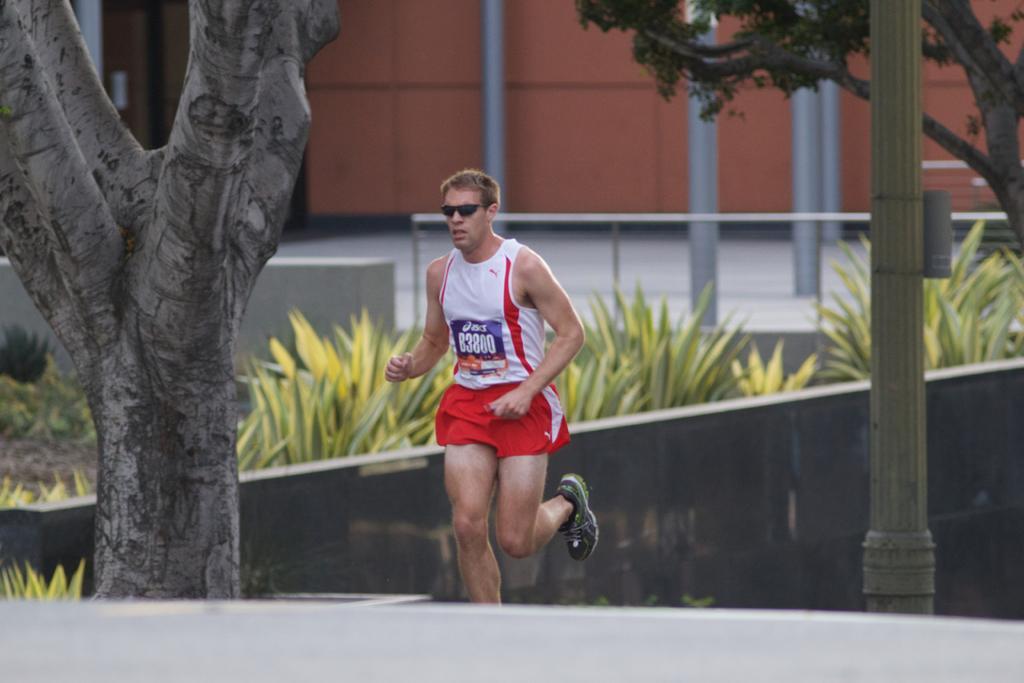In one or two sentences, can you explain what this image depicts? In the picture we can see a man jogging on the path, besides to him we can see trees, wall and behind it, we can see some plants, railing, building walls and some poles beside it. 